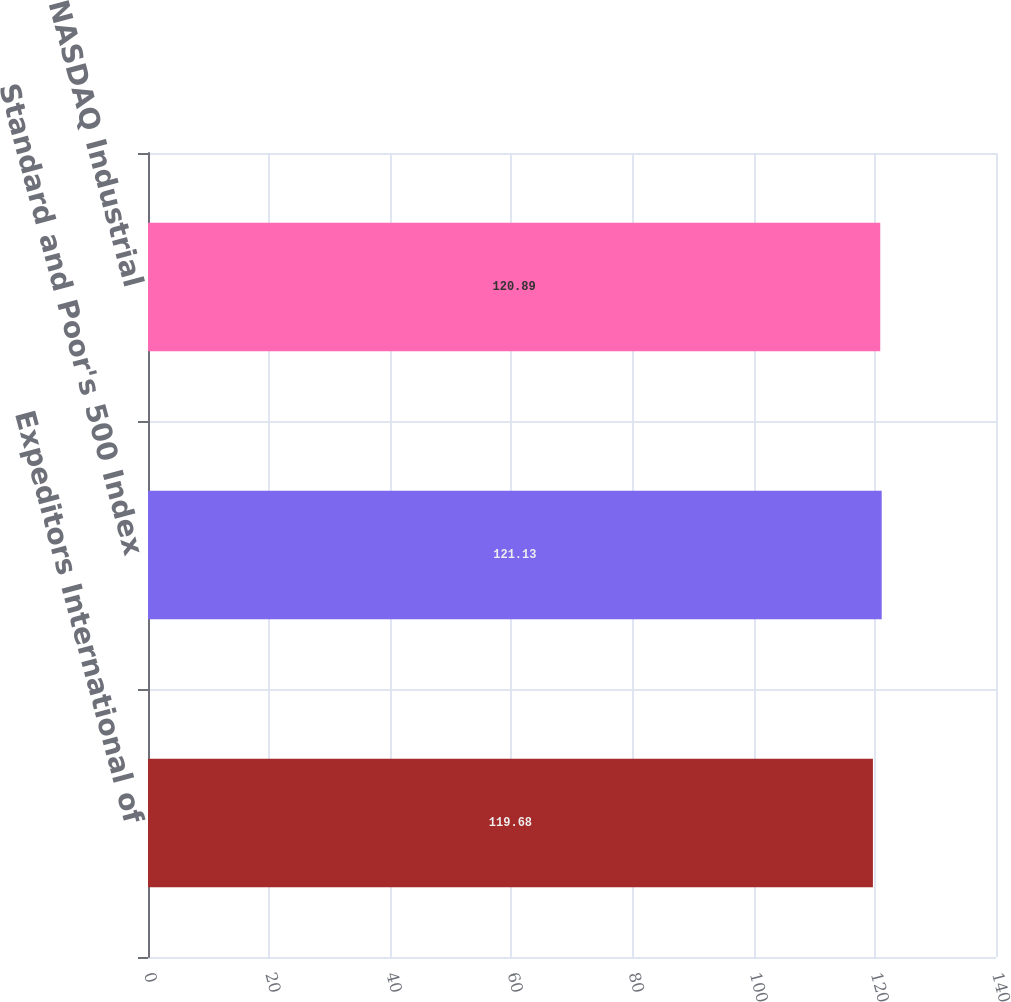Convert chart. <chart><loc_0><loc_0><loc_500><loc_500><bar_chart><fcel>Expeditors International of<fcel>Standard and Poor's 500 Index<fcel>NASDAQ Industrial<nl><fcel>119.68<fcel>121.13<fcel>120.89<nl></chart> 